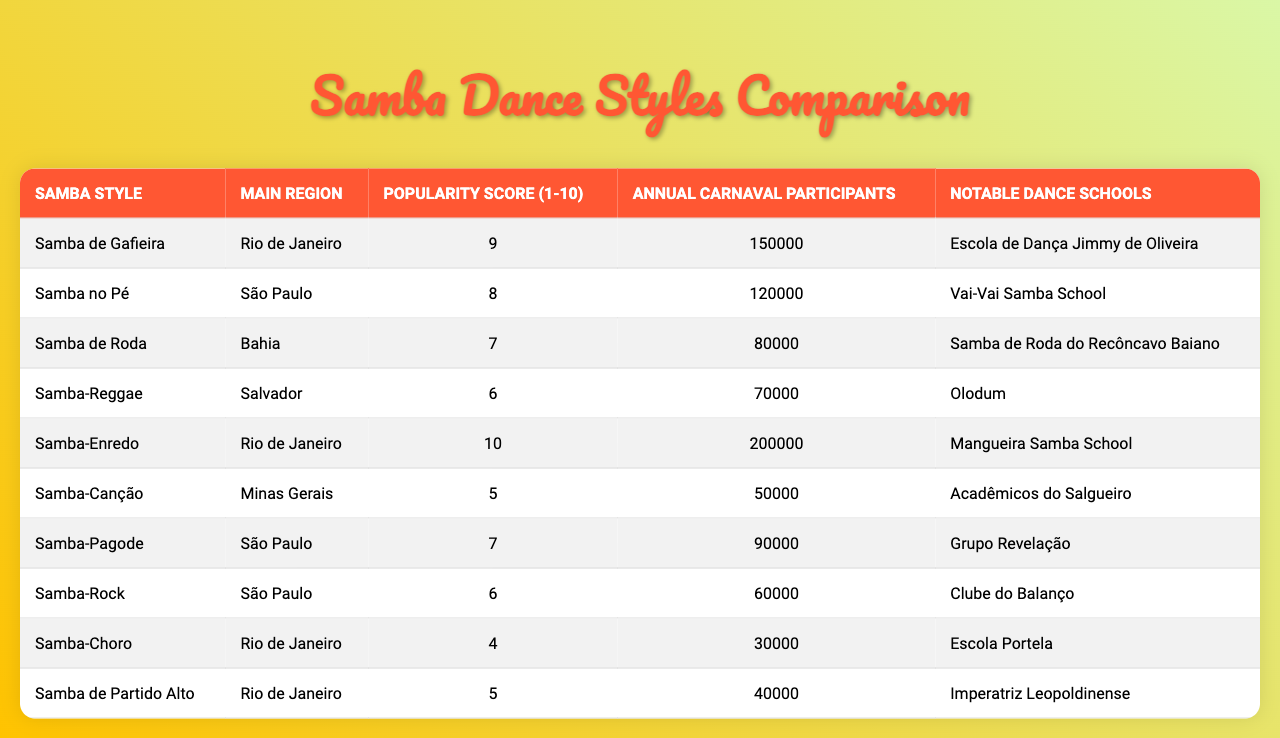What is the popularity score of Samba-Enredo? The table provides a specific column for the popularity score of each samba style. Looking up Samba-Enredo, its popularity score is listed as 10.
Answer: 10 Which samba style has the highest number of annual Carnaval participants? The table lists the annual Carnaval participants for each samba style. By comparing these values, Samba-Enredo has the highest participant count at 200,000.
Answer: Samba-Enredo Is Samba-Canção more popular than Samba de Roda? The popularity scores in the table show that Samba-Canção has a score of 5, while Samba de Roda has a score of 7. Since 5 is less than 7, Samba-Canção is not more popular.
Answer: No What is the average popularity score for samba styles originating from São Paulo? The samba styles from São Paulo are Samba no Pé (score 8), Samba-Pagode (score 7), and Samba-Rock (score 6). Adding these scores gives 8 + 7 + 6 = 21. Dividing by 3 gives an average score of 21 / 3 = 7.
Answer: 7 How many annual Carnaval participants are there in total for all samba styles from Rio de Janeiro? From the table, the samba styles from Rio de Janeiro are Samba de Gafieira (150,000), Samba-Enredo (200,000), Samba-Choro (30,000), and Samba de Partido Alto (40,000). Adding these gives 150,000 + 200,000 + 30,000 + 40,000 = 420,000.
Answer: 420,000 Which samba style from Bahia has the lowest popularity score? The table indicates that Samba de Roda from Bahia has a popularity score of 7, which is the only style listed from Bahia. Therefore, it is also the lowest by default.
Answer: 7 Is there a samba style from Minas Gerais that has a popularity score of 6 or higher? According to the table, the only samba style listed from Minas Gerais is Samba-Canção with a score of 5. This indicates that there is no samba style from Minas Gerais with a score of 6 or higher.
Answer: No What is the difference in popularity score between the most and least popular samba styles in the table? The most popular style is Samba-Enredo with a score of 10, and the least popular is Samba-Choro with a score of 4. The difference is calculated by subtracting the lower score from the higher score: 10 - 4 = 6.
Answer: 6 Which samba style has the same main region as Samba de Gafieira? The main region of Samba de Gafieira is Rio de Janeiro. Reviewing the table, the other samba styles from Rio de Janeiro include Samba-Enredo, Samba-Choro, and Samba de Partido Alto.
Answer: Samba-Enredo, Samba-Choro, Samba de Partido Alto What is the most popular samba style and its notable dance school? The most popular samba style is Samba-Enredo with a popularity score of 10. Its notable dance school, as mentioned in the table, is Mangueira Samba School.
Answer: Samba-Enredo; Mangueira Samba School 